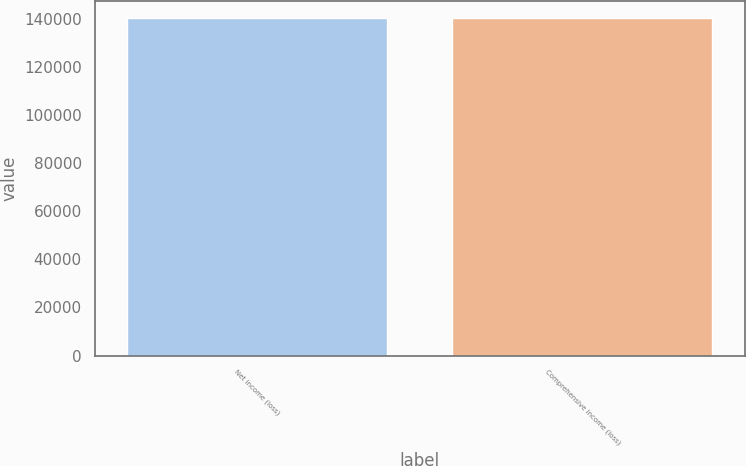<chart> <loc_0><loc_0><loc_500><loc_500><bar_chart><fcel>Net income (loss)<fcel>Comprehensive income (loss)<nl><fcel>140476<fcel>140355<nl></chart> 